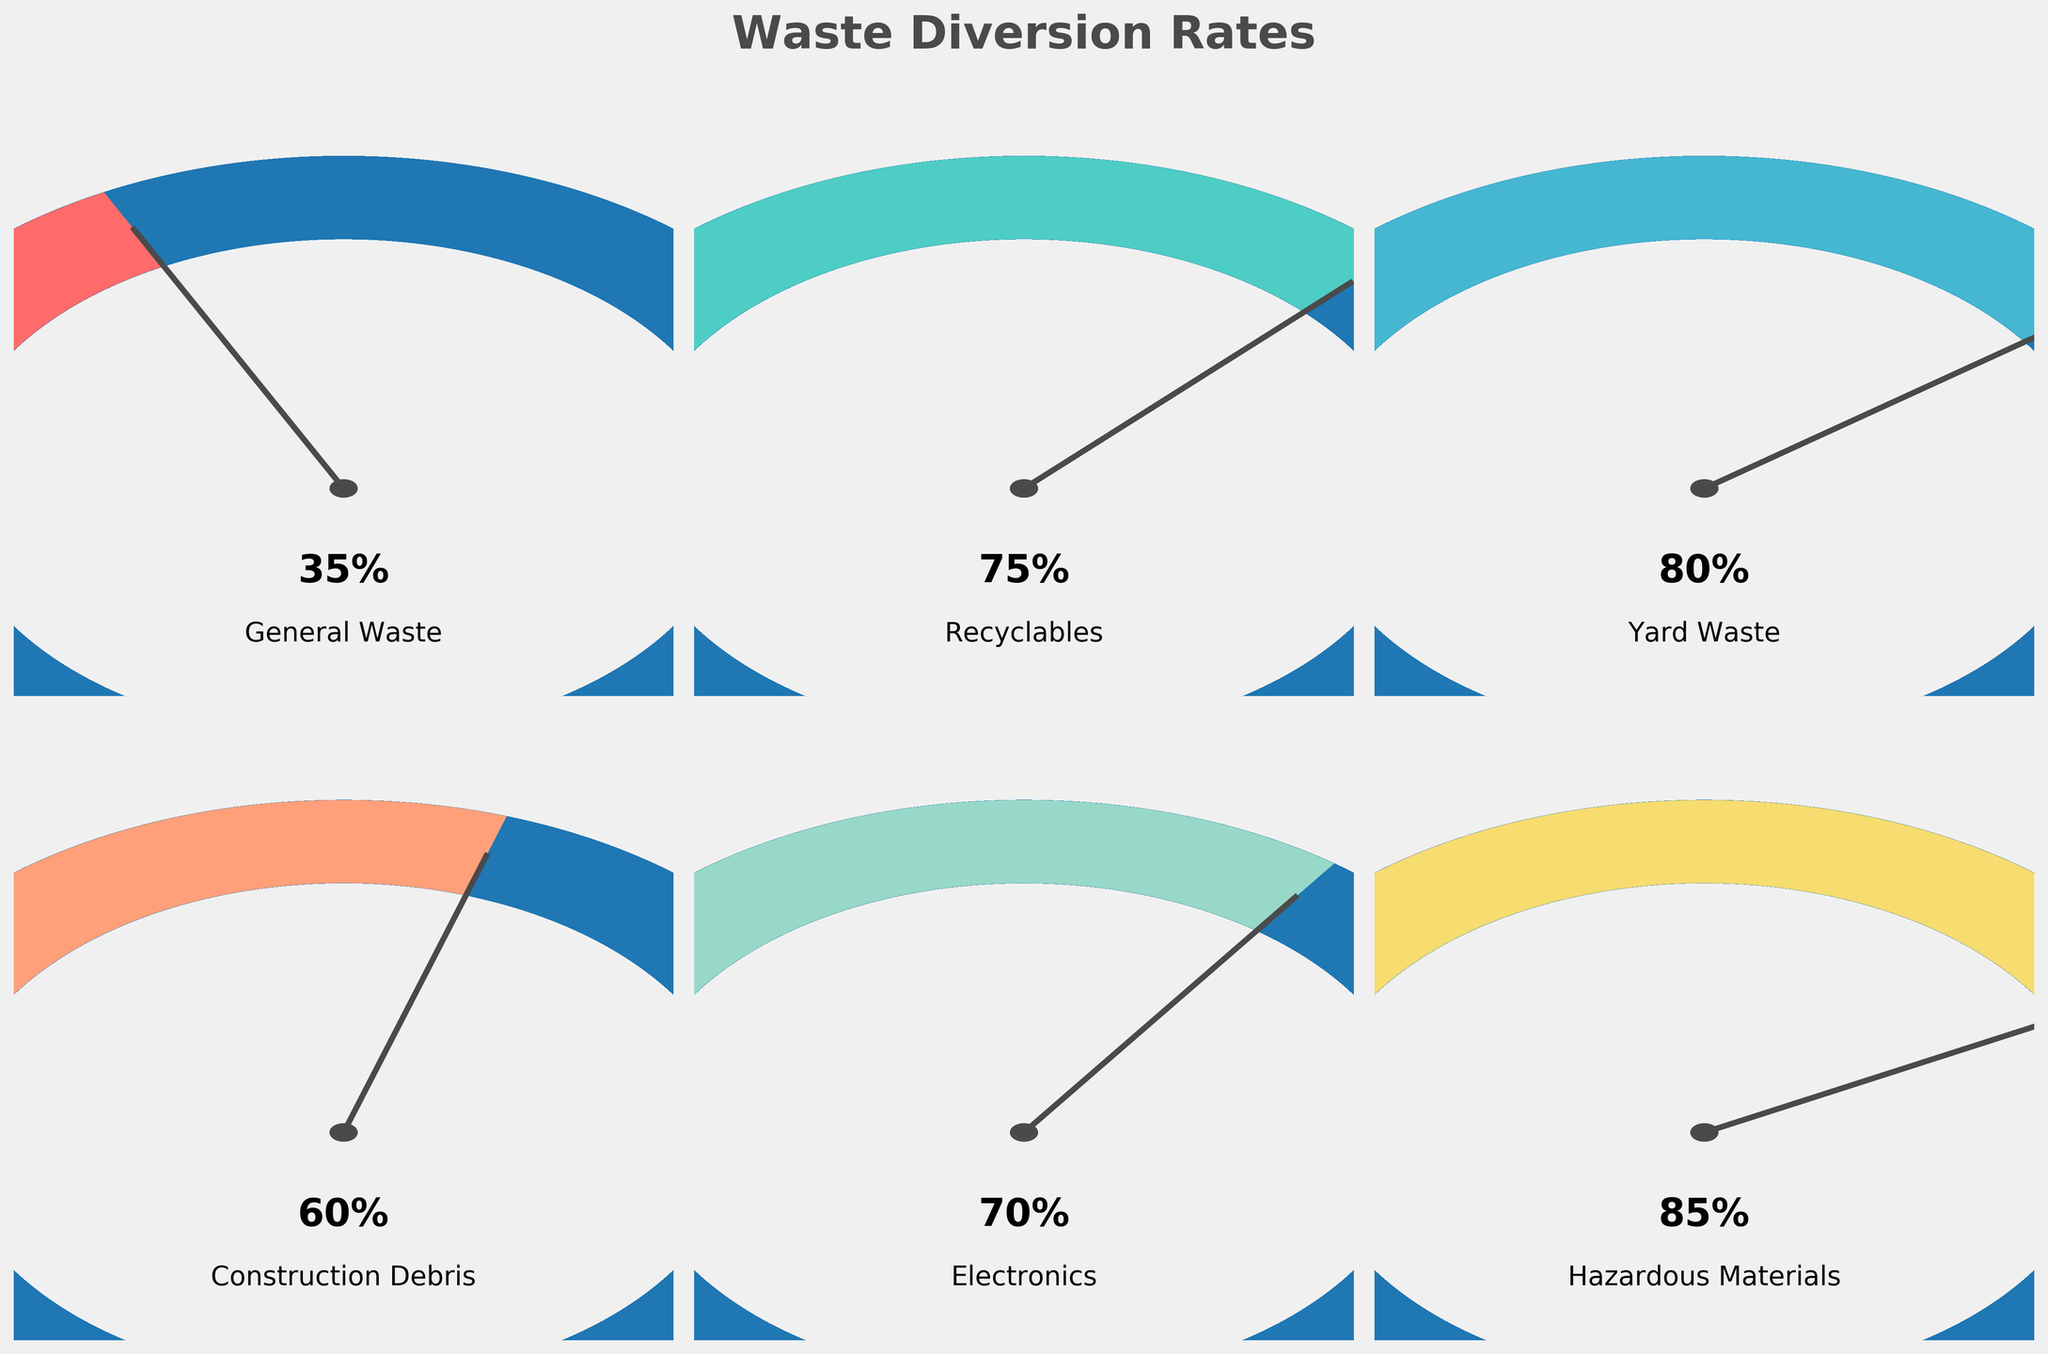What is the title of the figure? The title is the text at the top of the figure, which summarizes what the chart represents. It is written in a larger, bold font.
Answer: Waste Diversion Rates What waste type has the highest diversion rate? To find the waste type with the highest diversion rate, check each gauge chart and identify the one with the highest indicator value closest to 100%.
Answer: Hazardous Materials How does the diversion rate of Electronics compare to that of Yard Waste? Compare the values below each gauge chart. Electronics has a 70% diversion rate, while Yard Waste has an 80% diversion rate. 80% is greater than 70%.
Answer: Yard Waste has a higher diversion rate than Electronics Which waste types have a diversion rate of 60% or higher? Look at the values under each gauge chart to identify which ones are 60% or higher. These are Recyclables (75%), Yard Waste (80%), Construction Debris (60%), Electronics (70%), and Hazardous Materials (85%).
Answer: Recyclables, Yard Waste, Construction Debris, Electronics, Hazardous Materials What is the average diversion rate of all waste types? Calculate the average by adding up all diversion rates and dividing by the number of waste types: (35% + 75% + 80% + 60% + 70% + 85%) / 6.
Answer: The average is 67.5% Which waste type has the lowest diversion rate, and what is it? Identify the gauge chart with the lowest value, which is 35%, under the label "General Waste."
Answer: General Waste, 35% Is there any waste type with a diversion rate exactly halfway (50%) or greater but not exceeding 70%? Check the gauge charts for values in the range greater than or equal to 50% but less than or equal to 70%. This includes General Waste (35%), Construction Debris (60%), Electronics (70%)
Answer: Construction Debris (60%), Electronics (70%) What trend is observed in the diversion rates of Recyclables and Yard Waste? Note that both Recyclables and Yard Waste have high diversion rates, indicating effective recycling and sorting efforts for these waste types. Recyclables is 75%, and Yard Waste is 80%.
Answer: Both have high diversion rates How does the diversion rate of Construction Debris compare to the overall average? First, calculate the average diversion rate as 67.5%. Construction Debris has a diversion rate of 60%. Compare these two values.
Answer: Construction Debris rate (60%) is below the overall average (67.5%) What is the median diversion rate across all waste types? List the diversion rates in ascending order: 35%, 60%, 70%, 75%, 80%, 85%. The median is the average of the two middle values (70% and 75%).
Answer: Median rate is 72.5% 